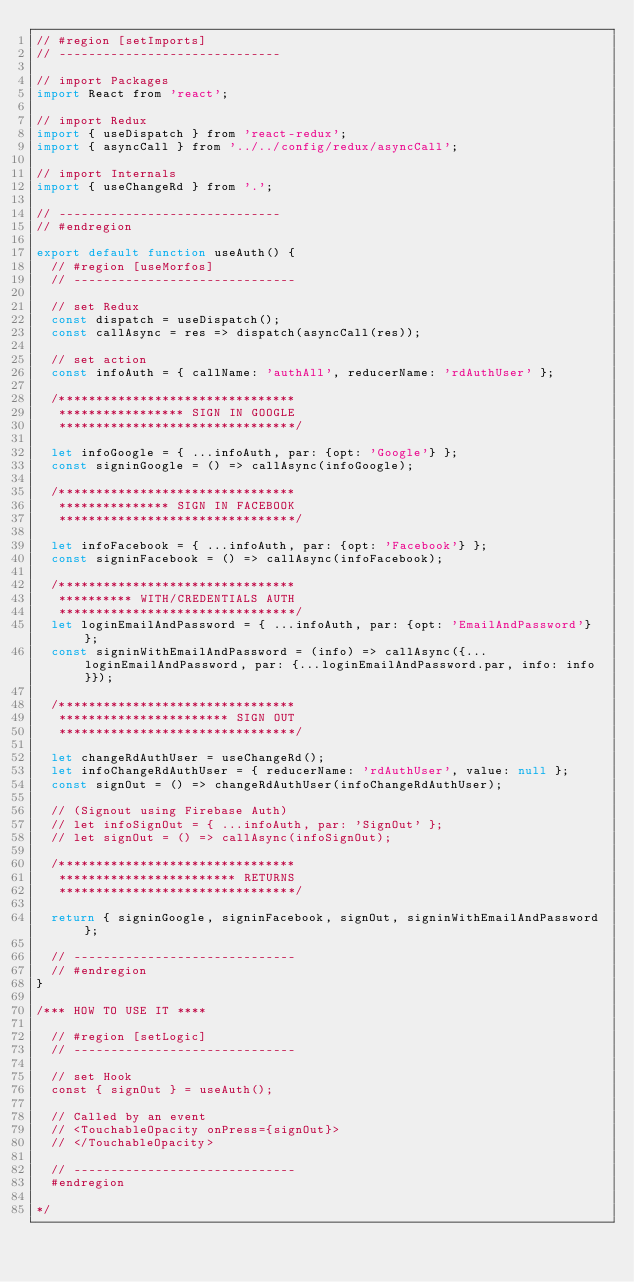<code> <loc_0><loc_0><loc_500><loc_500><_JavaScript_>// #region [setImports]
// ------------------------------

// import Packages
import React from 'react';

// import Redux
import { useDispatch } from 'react-redux';
import { asyncCall } from '../../config/redux/asyncCall';

// import Internals
import { useChangeRd } from '.';

// ------------------------------
// #endregion

export default function useAuth() {
  // #region [useMorfos]
  // ------------------------------

  // set Redux
  const dispatch = useDispatch();
  const callAsync = res => dispatch(asyncCall(res));

  // set action
  const infoAuth = { callName: 'authAll', reducerName: 'rdAuthUser' };

  /********************************
   ***************** SIGN IN GOOGLE
   ********************************/

  let infoGoogle = { ...infoAuth, par: {opt: 'Google'} };
  const signinGoogle = () => callAsync(infoGoogle);

  /********************************
   *************** SIGN IN FACEBOOK
   ********************************/

  let infoFacebook = { ...infoAuth, par: {opt: 'Facebook'} };
  const signinFacebook = () => callAsync(infoFacebook);

  /********************************
   ********** WITH/CREDENTIALS AUTH
   ********************************/
  let loginEmailAndPassword = { ...infoAuth, par: {opt: 'EmailAndPassword'} };
  const signinWithEmailAndPassword = (info) => callAsync({...loginEmailAndPassword, par: {...loginEmailAndPassword.par, info: info}});

  /********************************
   *********************** SIGN OUT
   ********************************/

  let changeRdAuthUser = useChangeRd();
  let infoChangeRdAuthUser = { reducerName: 'rdAuthUser', value: null };
  const signOut = () => changeRdAuthUser(infoChangeRdAuthUser);

  // (Signout using Firebase Auth)
  // let infoSignOut = { ...infoAuth, par: 'SignOut' };
  // let signOut = () => callAsync(infoSignOut);

  /********************************
   ************************ RETURNS
   ********************************/

  return { signinGoogle, signinFacebook, signOut, signinWithEmailAndPassword };

  // ------------------------------
  // #endregion
}

/*** HOW TO USE IT ****

  // #region [setLogic]
  // ------------------------------

  // set Hook
  const { signOut } = useAuth();

  // Called by an event
  // <TouchableOpacity onPress={signOut}>
  // </TouchableOpacity>

  // ------------------------------
  #endregion

*/
</code> 